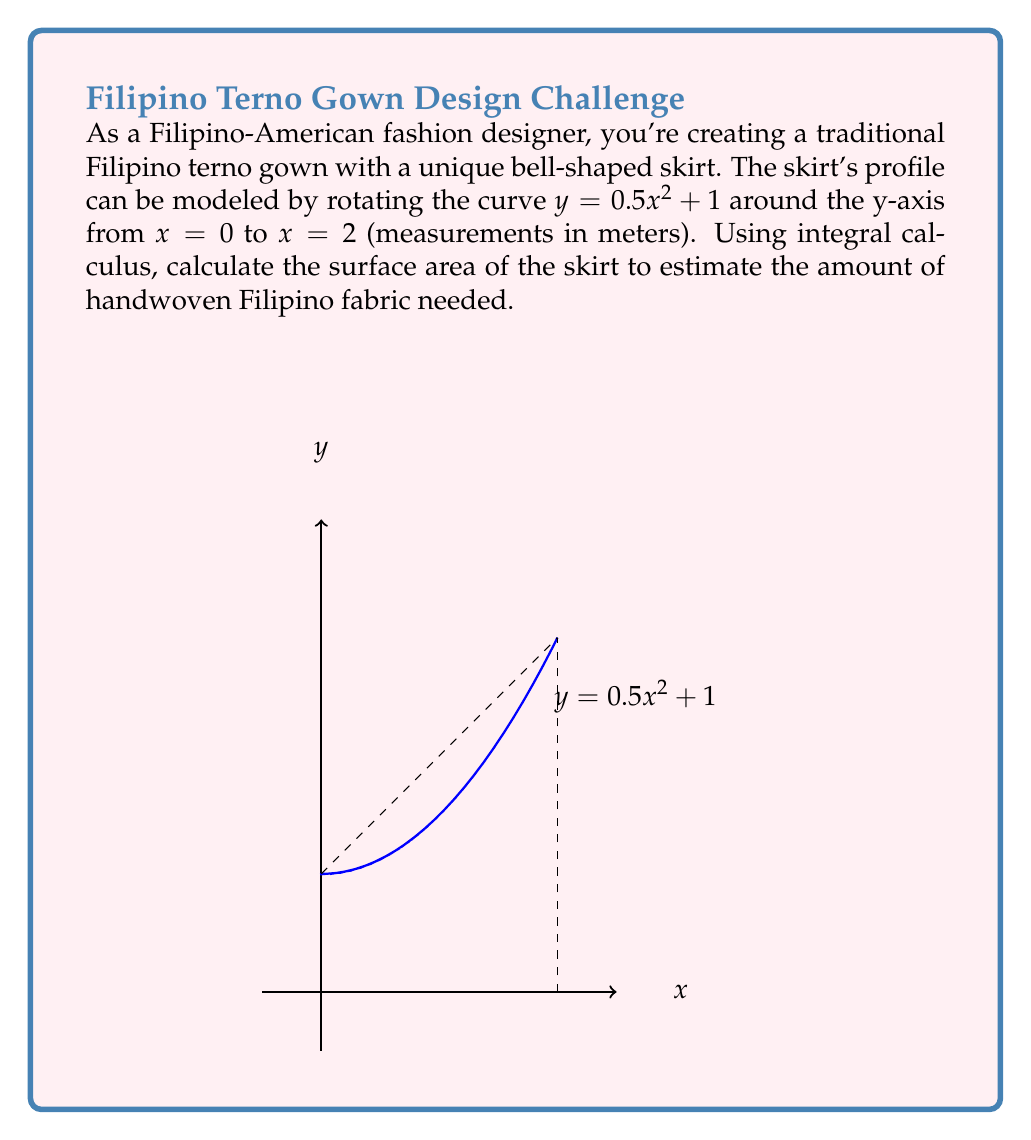Can you answer this question? To find the surface area of the skirt, we need to use the formula for the surface area of a solid of revolution:

$$S = 2\pi \int_a^b f(x) \sqrt{1 + [f'(x)]^2} dx$$

Where $f(x) = 0.5x^2 + 1$ and $f'(x) = x$

Step 1: Set up the integral
$$S = 2\pi \int_0^2 (0.5x^2 + 1) \sqrt{1 + x^2} dx$$

Step 2: This integral is complex, so we'll use u-substitution
Let $u = 1 + x^2$, then $du = 2x dx$ and $x dx = \frac{1}{2} du$

Step 3: Rewrite the integral in terms of u
$$S = 2\pi \int_1^5 (\frac{u}{2}) \sqrt{u} \cdot \frac{1}{2} du = \frac{\pi}{2} \int_1^5 u^{3/2} du$$

Step 4: Integrate
$$S = \frac{\pi}{2} \cdot \frac{2}{5} u^{5/2} \Big|_1^5 = \frac{\pi}{5} (5^{5/2} - 1^{5/2})$$

Step 5: Evaluate
$$S = \frac{\pi}{5} (55.90169 - 1) \approx 34.51 \text{ m}^2$$

Therefore, approximately 34.51 square meters of fabric are needed for the skirt.
Answer: $34.51 \text{ m}^2$ 